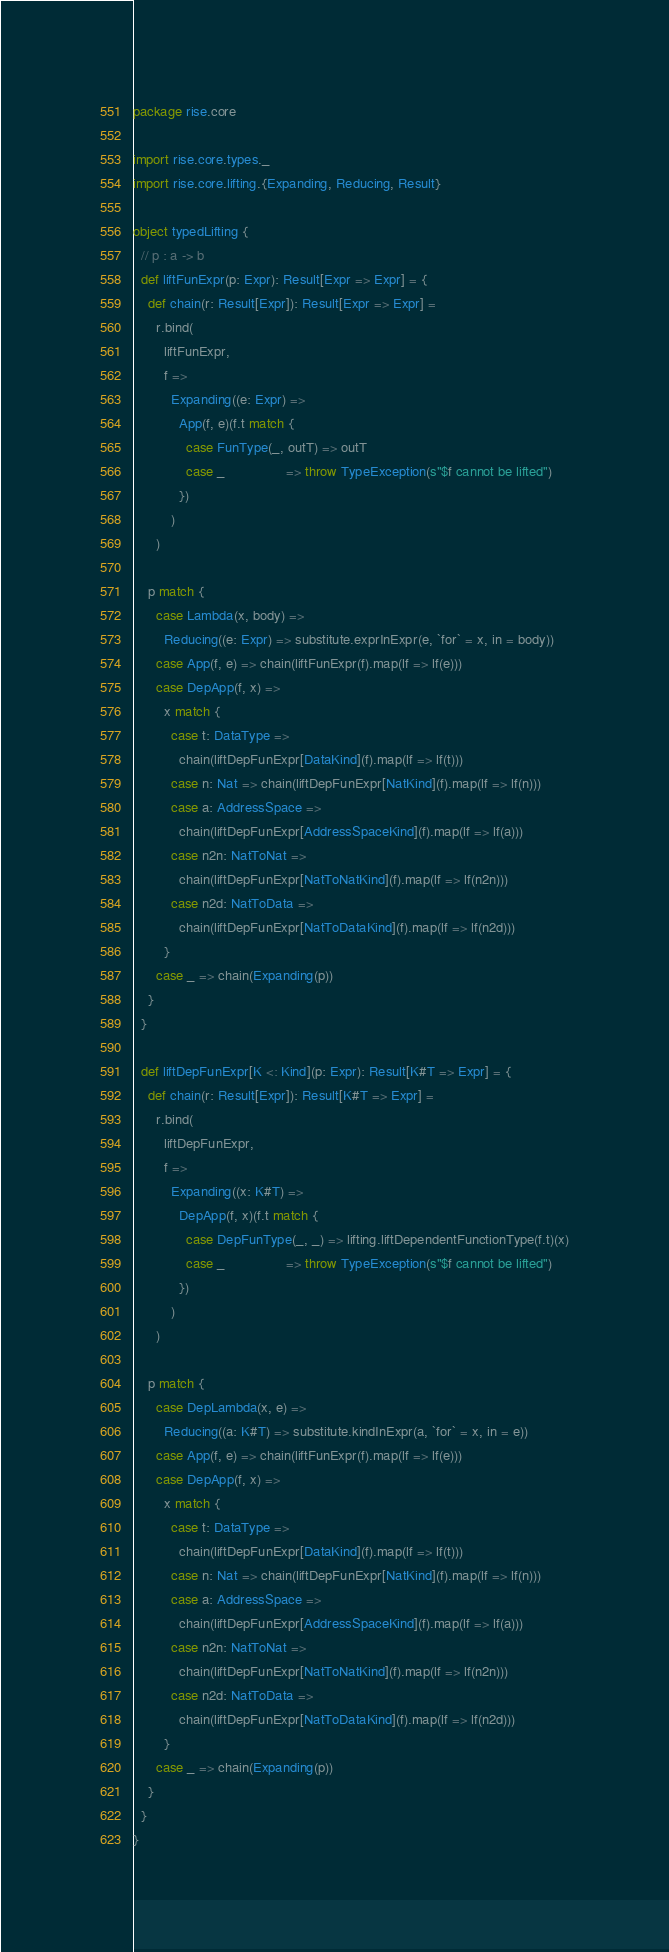Convert code to text. <code><loc_0><loc_0><loc_500><loc_500><_Scala_>package rise.core

import rise.core.types._
import rise.core.lifting.{Expanding, Reducing, Result}

object typedLifting {
  // p : a -> b
  def liftFunExpr(p: Expr): Result[Expr => Expr] = {
    def chain(r: Result[Expr]): Result[Expr => Expr] =
      r.bind(
        liftFunExpr,
        f =>
          Expanding((e: Expr) =>
            App(f, e)(f.t match {
              case FunType(_, outT) => outT
              case _                => throw TypeException(s"$f cannot be lifted")
            })
          )
      )

    p match {
      case Lambda(x, body) =>
        Reducing((e: Expr) => substitute.exprInExpr(e, `for` = x, in = body))
      case App(f, e) => chain(liftFunExpr(f).map(lf => lf(e)))
      case DepApp(f, x) =>
        x match {
          case t: DataType =>
            chain(liftDepFunExpr[DataKind](f).map(lf => lf(t)))
          case n: Nat => chain(liftDepFunExpr[NatKind](f).map(lf => lf(n)))
          case a: AddressSpace =>
            chain(liftDepFunExpr[AddressSpaceKind](f).map(lf => lf(a)))
          case n2n: NatToNat =>
            chain(liftDepFunExpr[NatToNatKind](f).map(lf => lf(n2n)))
          case n2d: NatToData =>
            chain(liftDepFunExpr[NatToDataKind](f).map(lf => lf(n2d)))
        }
      case _ => chain(Expanding(p))
    }
  }

  def liftDepFunExpr[K <: Kind](p: Expr): Result[K#T => Expr] = {
    def chain(r: Result[Expr]): Result[K#T => Expr] =
      r.bind(
        liftDepFunExpr,
        f =>
          Expanding((x: K#T) =>
            DepApp(f, x)(f.t match {
              case DepFunType(_, _) => lifting.liftDependentFunctionType(f.t)(x)
              case _                => throw TypeException(s"$f cannot be lifted")
            })
          )
      )

    p match {
      case DepLambda(x, e) =>
        Reducing((a: K#T) => substitute.kindInExpr(a, `for` = x, in = e))
      case App(f, e) => chain(liftFunExpr(f).map(lf => lf(e)))
      case DepApp(f, x) =>
        x match {
          case t: DataType =>
            chain(liftDepFunExpr[DataKind](f).map(lf => lf(t)))
          case n: Nat => chain(liftDepFunExpr[NatKind](f).map(lf => lf(n)))
          case a: AddressSpace =>
            chain(liftDepFunExpr[AddressSpaceKind](f).map(lf => lf(a)))
          case n2n: NatToNat =>
            chain(liftDepFunExpr[NatToNatKind](f).map(lf => lf(n2n)))
          case n2d: NatToData =>
            chain(liftDepFunExpr[NatToDataKind](f).map(lf => lf(n2d)))
        }
      case _ => chain(Expanding(p))
    }
  }
}
</code> 